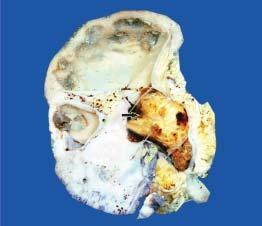does sectioned surface show dilated pelvicalyceal system with atrophied and thin peripheral cortex?
Answer the question using a single word or phrase. Yes 